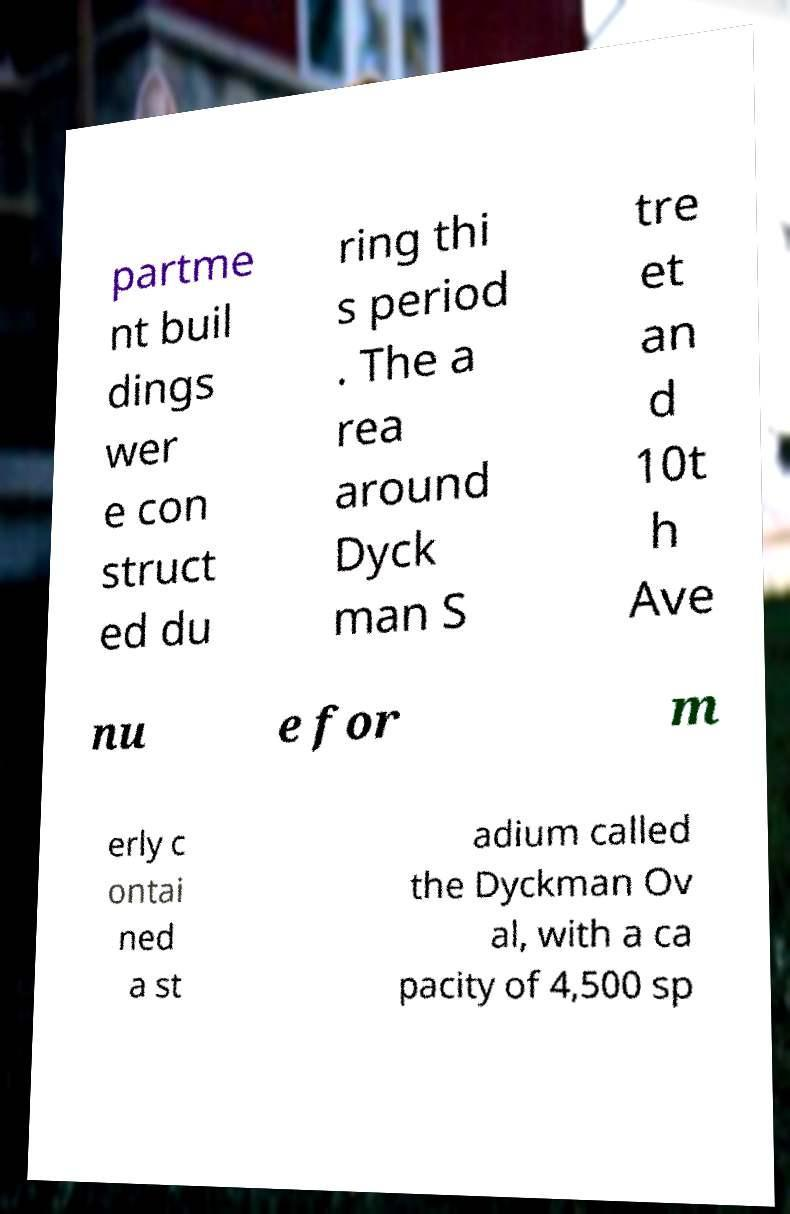Can you accurately transcribe the text from the provided image for me? partme nt buil dings wer e con struct ed du ring thi s period . The a rea around Dyck man S tre et an d 10t h Ave nu e for m erly c ontai ned a st adium called the Dyckman Ov al, with a ca pacity of 4,500 sp 